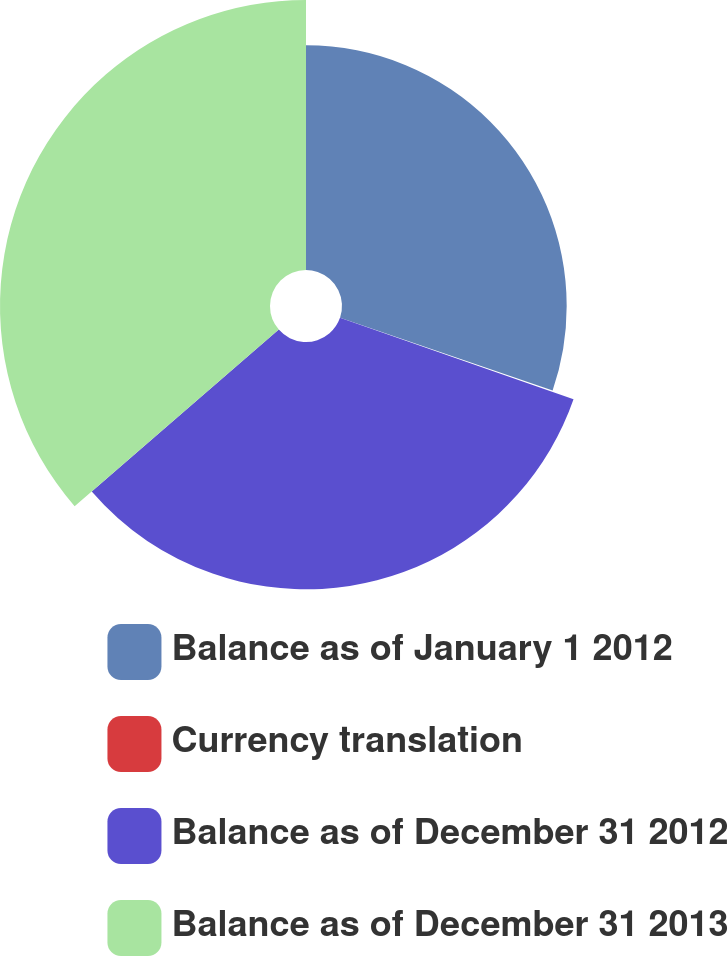Convert chart to OTSL. <chart><loc_0><loc_0><loc_500><loc_500><pie_chart><fcel>Balance as of January 1 2012<fcel>Currency translation<fcel>Balance as of December 31 2012<fcel>Balance as of December 31 2013<nl><fcel>30.25%<fcel>0.09%<fcel>33.3%<fcel>36.35%<nl></chart> 